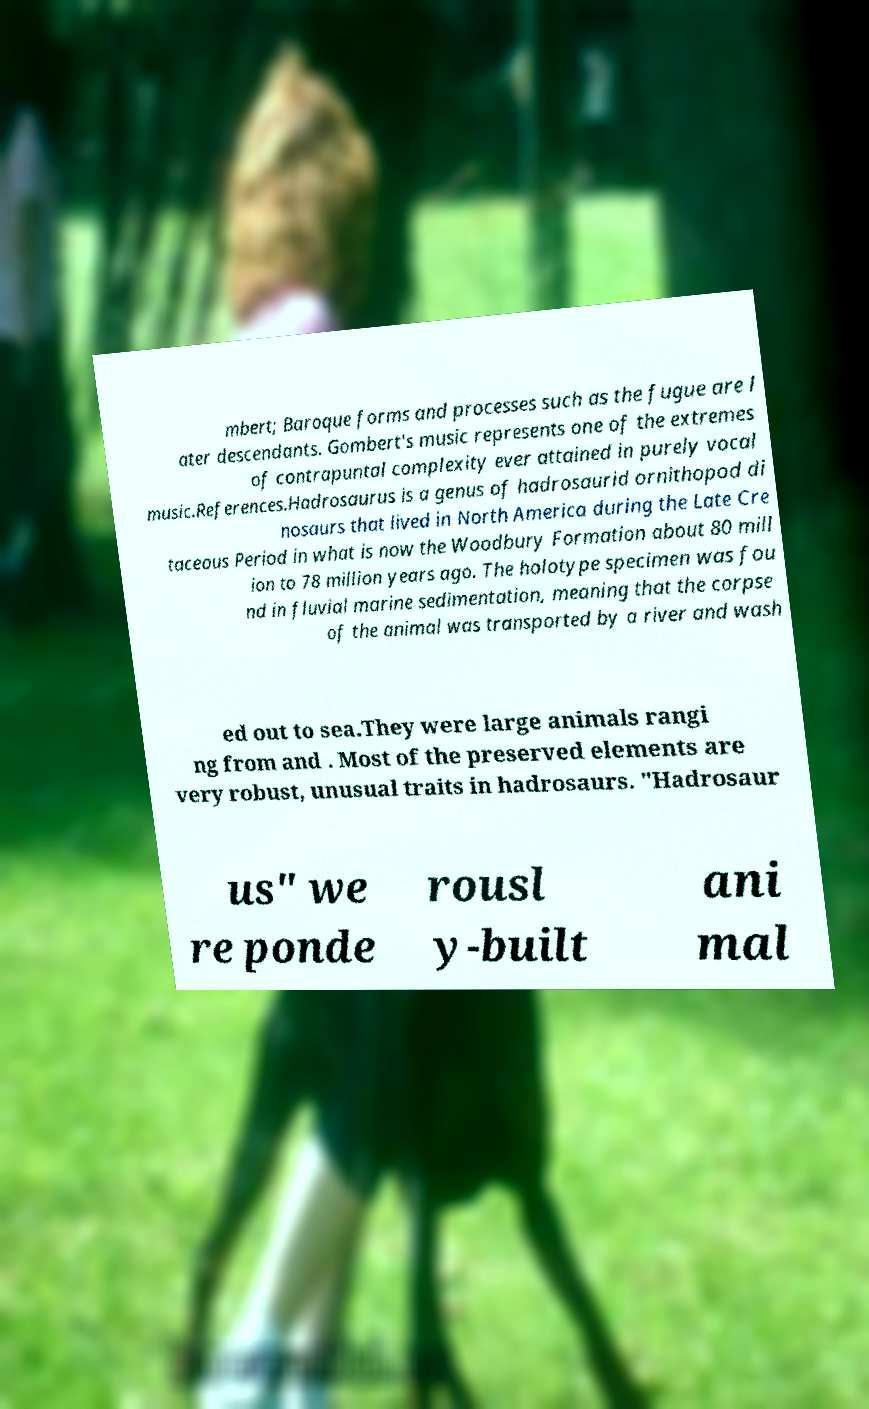Please read and relay the text visible in this image. What does it say? mbert; Baroque forms and processes such as the fugue are l ater descendants. Gombert's music represents one of the extremes of contrapuntal complexity ever attained in purely vocal music.References.Hadrosaurus is a genus of hadrosaurid ornithopod di nosaurs that lived in North America during the Late Cre taceous Period in what is now the Woodbury Formation about 80 mill ion to 78 million years ago. The holotype specimen was fou nd in fluvial marine sedimentation, meaning that the corpse of the animal was transported by a river and wash ed out to sea.They were large animals rangi ng from and . Most of the preserved elements are very robust, unusual traits in hadrosaurs. "Hadrosaur us" we re ponde rousl y-built ani mal 